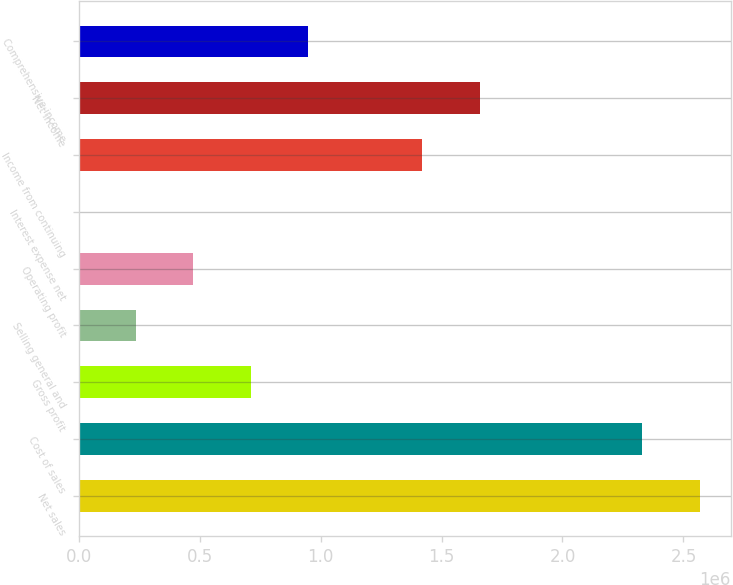<chart> <loc_0><loc_0><loc_500><loc_500><bar_chart><fcel>Net sales<fcel>Cost of sales<fcel>Gross profit<fcel>Selling general and<fcel>Operating profit<fcel>Interest expense net<fcel>Income from continuing<fcel>Net income<fcel>Comprehensive income<nl><fcel>2.56715e+06<fcel>2.33027e+06<fcel>710707<fcel>236955<fcel>473831<fcel>79<fcel>1.42134e+06<fcel>1.65821e+06<fcel>947583<nl></chart> 